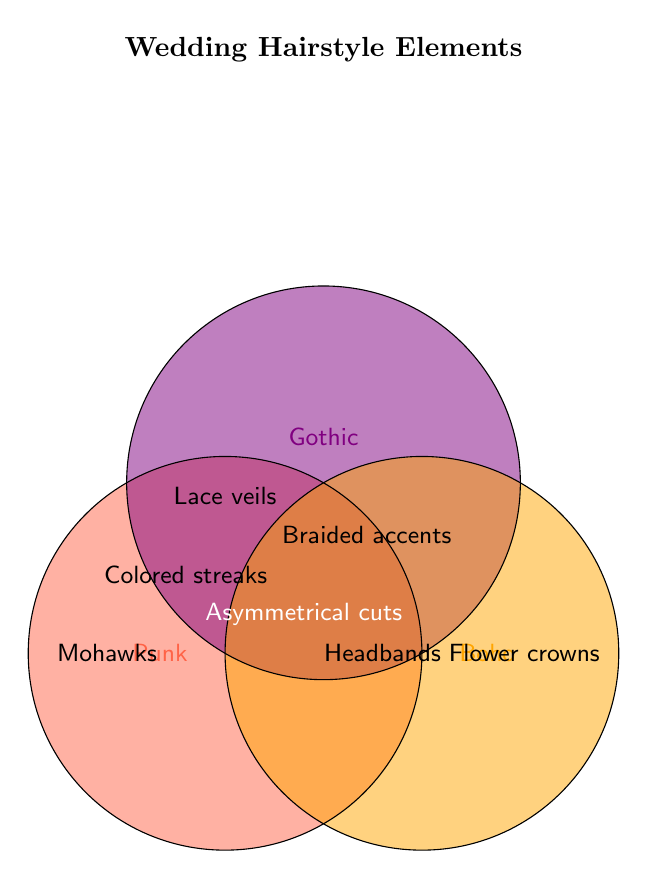What is the title of this Venn Diagram? The title is displayed at the top of the Venn Diagram, indicating what the chart is about.
Answer: Wedding Hairstyle Elements Which section contains 'Lace veils'? 'Lace veils' is found in the Gothic circle and it's not shared with other categories.
Answer: Gothic What elements are in the intersection of Punk and Gothic? The intersection of Punk and Gothic is the overlapping area between these two circles.
Answer: Colored streaks Which wedding hairstyle elements are unique to the Boho category? Elements in the Boho circle that do not intersect with Punk or Gothic.
Answer: Flower crowns What is the common element in the intersection of Punk, Gothic, and Boho? The section where all three circles overlap contains one element.
Answer: Unconventional colors How many elements are shared between Gothic and Boho but not Punk? Count the elements in the overlapping section between Gothic and Boho excluding the intersection with Punk.
Answer: 4 Which hairstyle elements are exclusive to the Punk category? Elements in the Punk circle that do not overlap with Gothic or Boho.
Answer: Mohawks, Safety pins, Spikes What's the total number of unique elements in the Boho circle including intersections? Sum the elements in Boho only, Boho & Punk, Boho & Gothic, and Boho & Punk & Gothic.
Answer: 8 Which category has 'Asymmetrical cuts'? Locate 'Asymmetrical cuts' present in one category only.
Answer: Punk What elements are found in both Punk and Boho but not Gothic? Check for elements in the intersecting area between Punk and Boho circles excluding Gothic circle.
Answer: Undercuts 